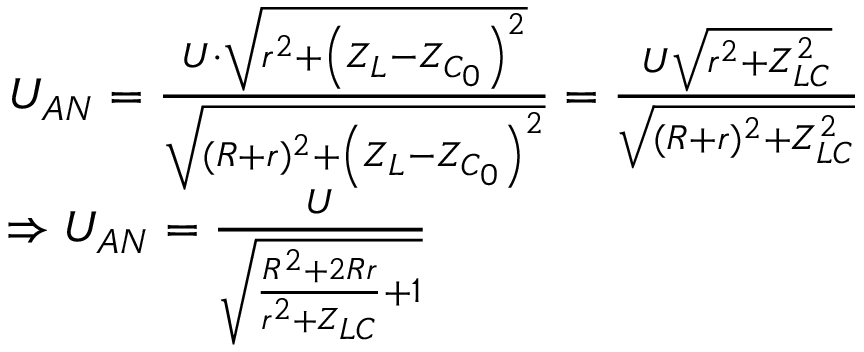<formula> <loc_0><loc_0><loc_500><loc_500>\begin{array} { r l } & { U _ { A N } = \frac { U \cdot \sqrt { r ^ { 2 } + \left ( Z _ { L } - Z _ { C _ { 0 } } \right ) ^ { 2 } } } { \sqrt { ( R + r ) ^ { 2 } + \left ( Z _ { L } - Z _ { C _ { 0 } } \right ) ^ { 2 } } } = \frac { U \sqrt { r ^ { 2 } + Z _ { L C } ^ { 2 } } } { \sqrt { ( R + r ) ^ { 2 } + Z _ { L C } ^ { 2 } } } } \\ & { \Rightarrow U _ { A N } = \frac { U } { \sqrt { \frac { R ^ { 2 } + 2 R r } { r ^ { 2 } + Z _ { L C } } + 1 } } } \end{array}</formula> 